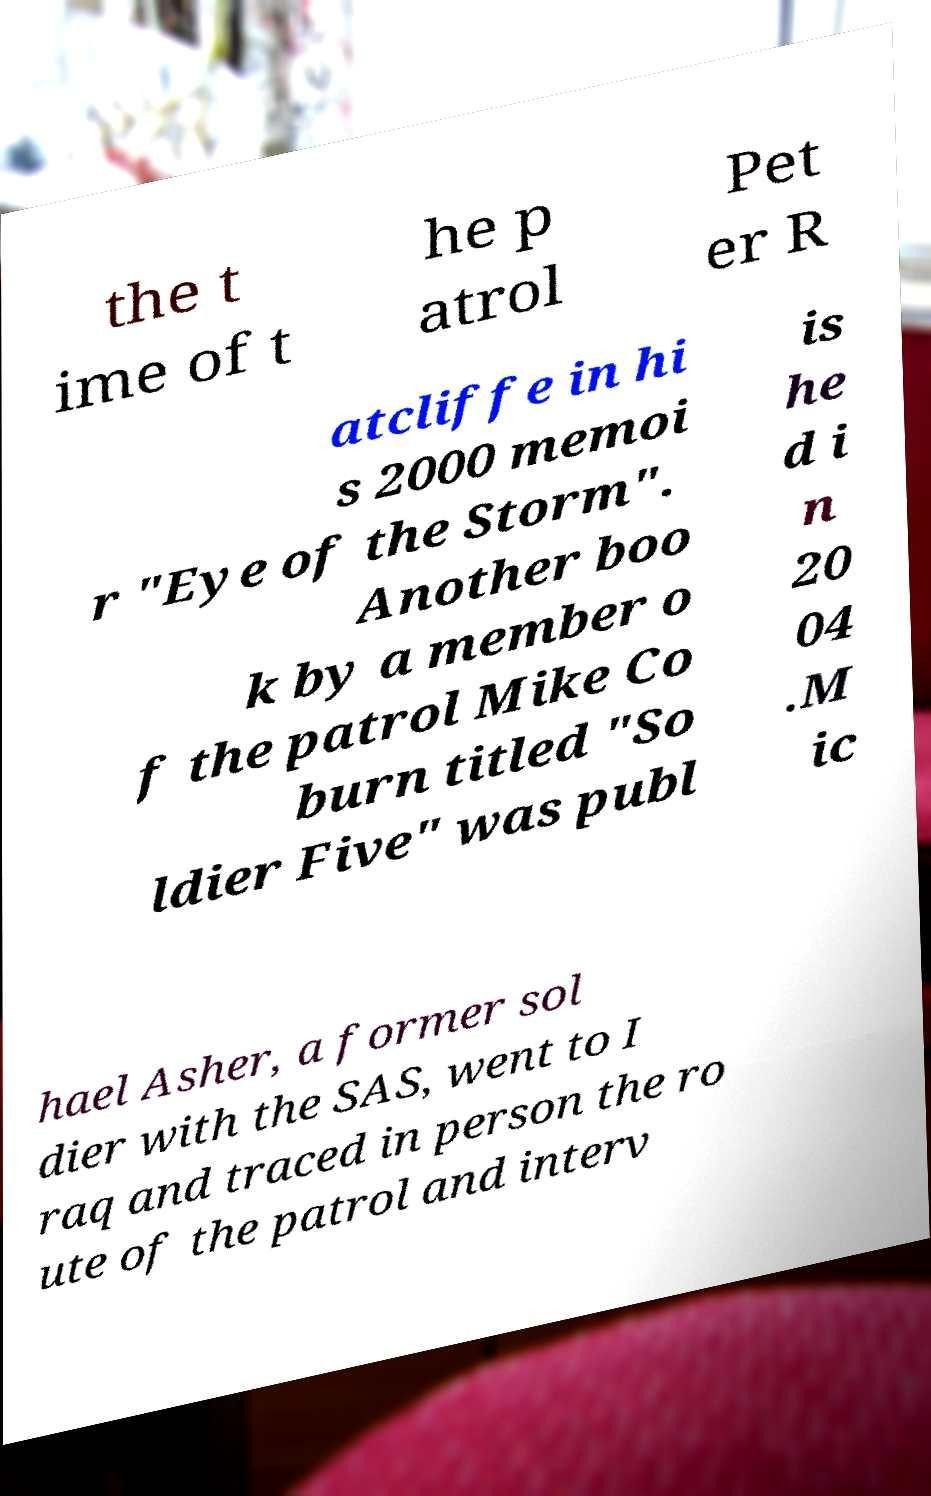Please identify and transcribe the text found in this image. the t ime of t he p atrol Pet er R atcliffe in hi s 2000 memoi r "Eye of the Storm". Another boo k by a member o f the patrol Mike Co burn titled "So ldier Five" was publ is he d i n 20 04 .M ic hael Asher, a former sol dier with the SAS, went to I raq and traced in person the ro ute of the patrol and interv 